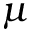<formula> <loc_0><loc_0><loc_500><loc_500>\mu</formula> 